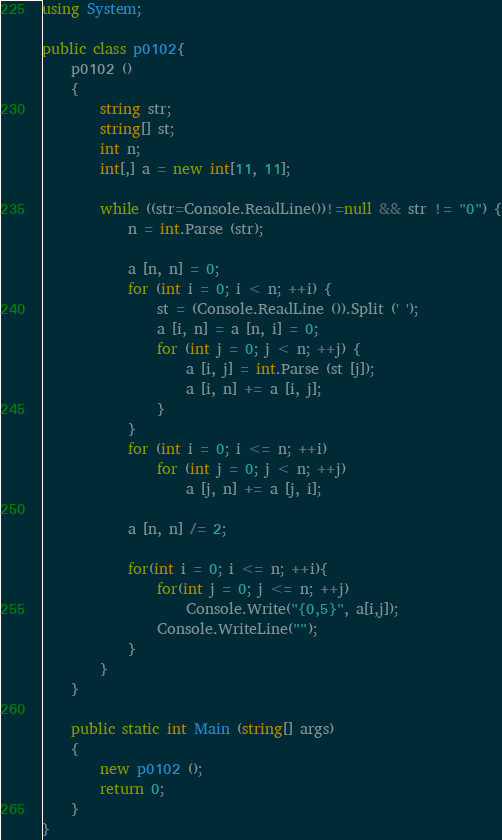<code> <loc_0><loc_0><loc_500><loc_500><_C#_>using System;

public class p0102{
	p0102 ()
	{
		string str;
		string[] st;
		int n;
		int[,] a = new int[11, 11];
		
		while ((str=Console.ReadLine())!=null && str != "0") {
			n = int.Parse (str);
			
			a [n, n] = 0;
			for (int i = 0; i < n; ++i) {
				st = (Console.ReadLine ()).Split (' ');
				a [i, n] = a [n, i] = 0;
				for (int j = 0; j < n; ++j) {
					a [i, j] = int.Parse (st [j]);
					a [i, n] += a [i, j];
				}
			}
			for (int i = 0; i <= n; ++i)
				for (int j = 0; j < n; ++j)
					a [j, n] += a [j, i];
			
			a [n, n] /= 2;
			
			for(int i = 0; i <= n; ++i){
				for(int j = 0; j <= n; ++j)
					Console.Write("{0,5}", a[i,j]);
				Console.WriteLine("");
			}
		}
	}
	
	public static int Main (string[] args)
	{
		new p0102 ();
		return 0;
	}
}</code> 